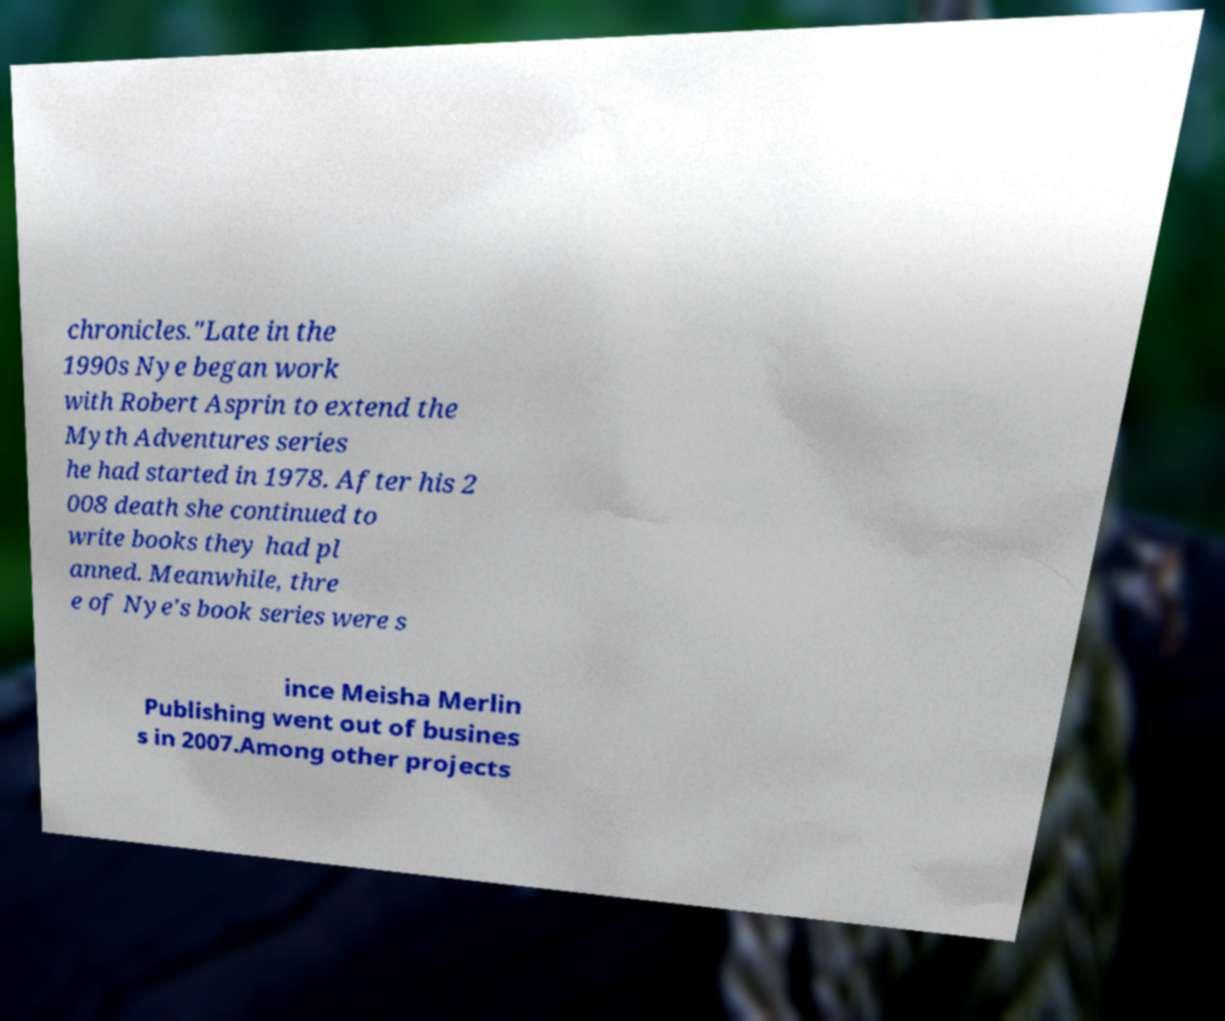Can you accurately transcribe the text from the provided image for me? chronicles."Late in the 1990s Nye began work with Robert Asprin to extend the Myth Adventures series he had started in 1978. After his 2 008 death she continued to write books they had pl anned. Meanwhile, thre e of Nye's book series were s ince Meisha Merlin Publishing went out of busines s in 2007.Among other projects 